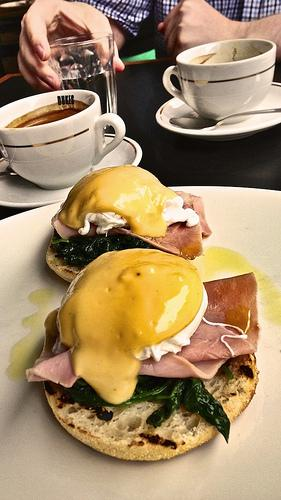Question: who is in the photo?
Choices:
A. Woman.
B. Boy.
C. A man.
D. Girl.
Answer with the letter. Answer: C Question: what color are the mugs?
Choices:
A. Brown.
B. Yellow.
C. Beige.
D. White.
Answer with the letter. Answer: D 